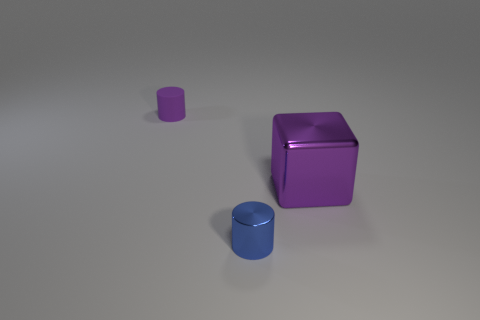Is there any other thing that has the same size as the purple metallic cube?
Provide a succinct answer. No. How many things are either small cylinders behind the tiny blue metal object or tiny cylinders in front of the rubber object?
Make the answer very short. 2. There is a object that is to the left of the cylinder right of the purple thing that is on the left side of the metallic cylinder; what is its size?
Your answer should be compact. Small. Is the number of purple metallic cubes that are to the right of the large purple object the same as the number of small purple things?
Make the answer very short. No. Are there any other things that have the same shape as the tiny purple rubber thing?
Provide a short and direct response. Yes. There is a matte object; is its shape the same as the metal thing that is behind the blue metal cylinder?
Provide a short and direct response. No. There is a blue thing that is the same shape as the purple matte object; what size is it?
Offer a very short reply. Small. How many other objects are the same material as the cube?
Make the answer very short. 1. What is the tiny blue cylinder made of?
Offer a very short reply. Metal. There is a small cylinder that is on the left side of the blue cylinder; is it the same color as the small object right of the rubber cylinder?
Ensure brevity in your answer.  No. 